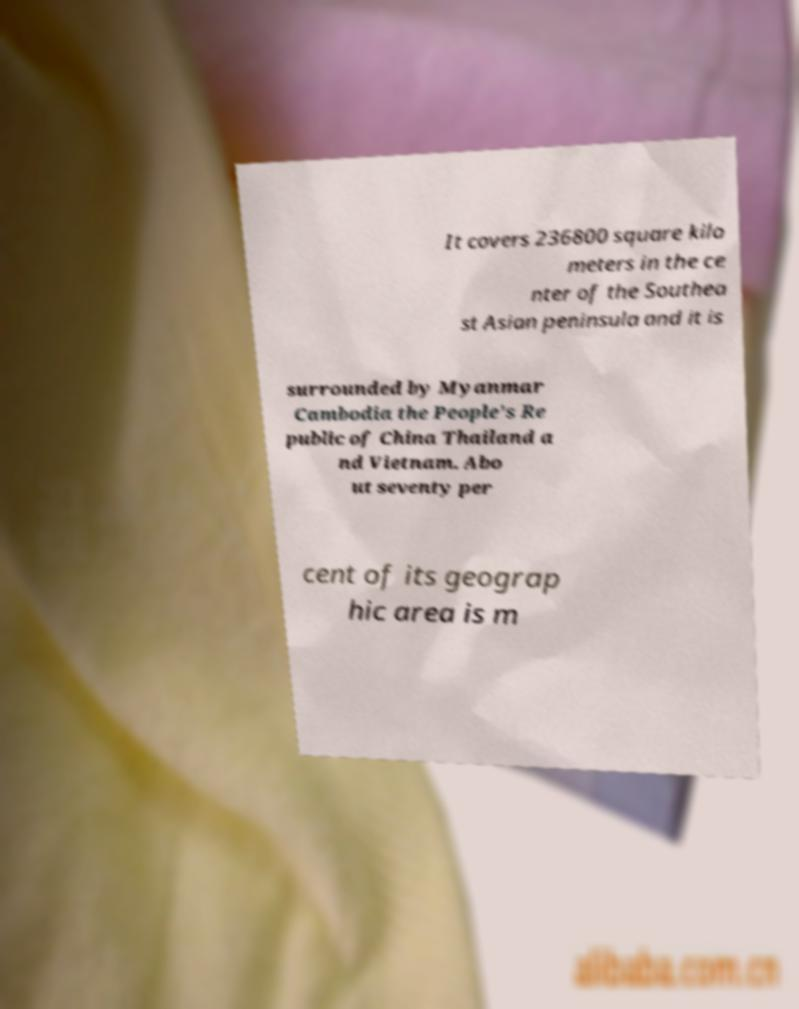For documentation purposes, I need the text within this image transcribed. Could you provide that? It covers 236800 square kilo meters in the ce nter of the Southea st Asian peninsula and it is surrounded by Myanmar Cambodia the People's Re public of China Thailand a nd Vietnam. Abo ut seventy per cent of its geograp hic area is m 